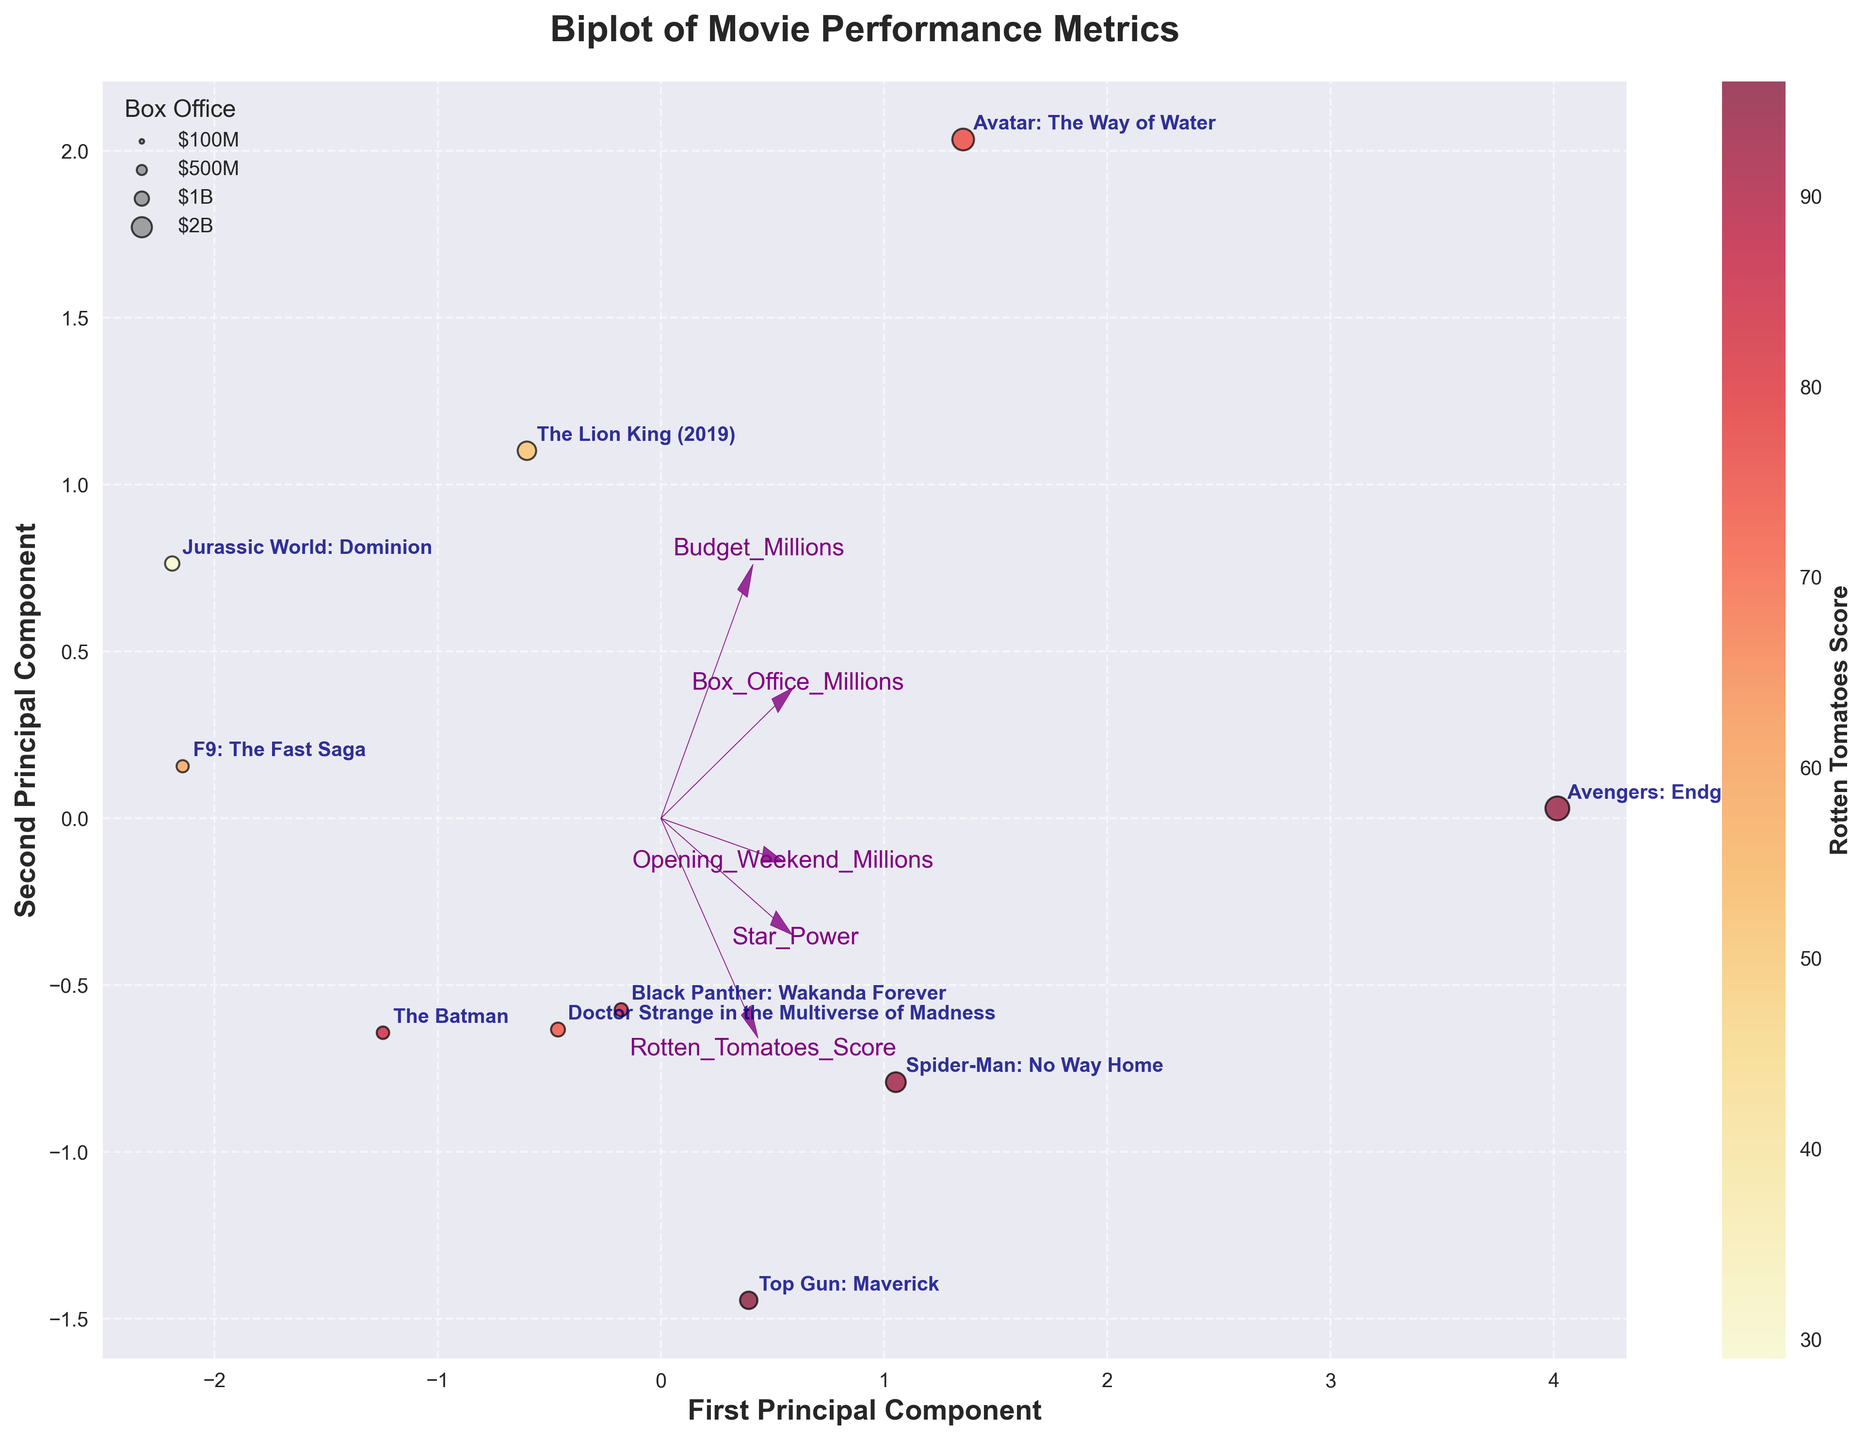What are the axes labeled as? The axes of the biplot are labeled on the x-axis as "First Principal Component" and the y-axis as "Second Principal Component". These represent the two principal components that capture the most variance in the data
Answer: First Principal Component, Second Principal Component How many movies are represented in the plot? By counting the number of labeled data points in the biplot, we can see that there are 10 movies represented. Each movie is labeled with its name on the plot
Answer: 10 Which movie has the highest Rotten Tomatoes Score? By observing the color gradient in the scatter plot, the movie with the highest score is indicated by the most intense color. "Top Gun: Maverick" has the highest Rotten Tomatoes Score at 96
Answer: Top Gun: Maverick Which movies have similar positions and what can this imply? "Avengers: Endgame" and "Spider-Man: No Way Home" are placed closely together. This implies that these movies have similar overall metrics in terms of box office performance, critical reception, star power, budget, and opening weekend performance
Answer: Avengers: Endgame, Spider-Man: No Way Home Compare the budget and box office revenue for 'Jurassic World: Dominion' and 'F9: The Fast Saga'. 'Jurassic World: Dominion' and 'F9: The Fast Saga' are shown in the plot with larger bubble sizes for 'Jurassic World: Dominion'. Both have similar budgets (~200 million), but 'Jurassic World: Dominion' made a higher box office revenue (1001M) compared to 'F9: The Fast Saga' (726M)
Answer: 'Jurassic World: Dominion' had higher box office revenue What's the relationship between 'Box Office' and 'Opening Weekend' for the movies? By looking at the plot, the feature vectors for 'Box Office' and 'Opening Weekend' are pointing in the same direction. This means there is a positive correlation between them, suggesting movies that perform well in their opening weekend also tend to do well overall at the box office
Answer: Positive correlation Is there a noticeable pattern between budget and Rotten Tomatoes Score? The vectors for 'Budget_Millions' and 'Rotten_Tomatoes_Score' are not well aligned, suggesting no strong direct relationship. The color gradient also shows that movies with higher budgets do not necessarily get higher Rotten Tomatoes Scores
Answer: No strong relationship Which movie had the lowest Rotten Tomatoes Score, and how does its Box Office compare? 'Jurassic World: Dominion' has the lowest Rotten Tomatoes Score at 29, shown by its darker color in the plot. Despite this, it still has a significant box office revenue, represented by a relatively large bubble
Answer: Jurassic World: Dominion Explain the significance of the vector directions in the biplot. The directions of the vectors indicate the direction of increase for each feature. The length of each vector indicates the importance of that feature in the PCA space. The angle between vectors reflects the correlation between features: small angles signify high correlation
Answer: Directions and angles indicate feature importance and correlations Which movie had the closest budget to 'The Lion King (2019)' but a higher Rotten Tomatoes Score? 'The Batman' and 'Doctor Strange in the Multiverse of Madness' have similar budgets to 'The Lion King (2019)' (~200M). However, 'The Batman' has a noticeably higher Rotten Tomatoes Score
Answer: The Batman 